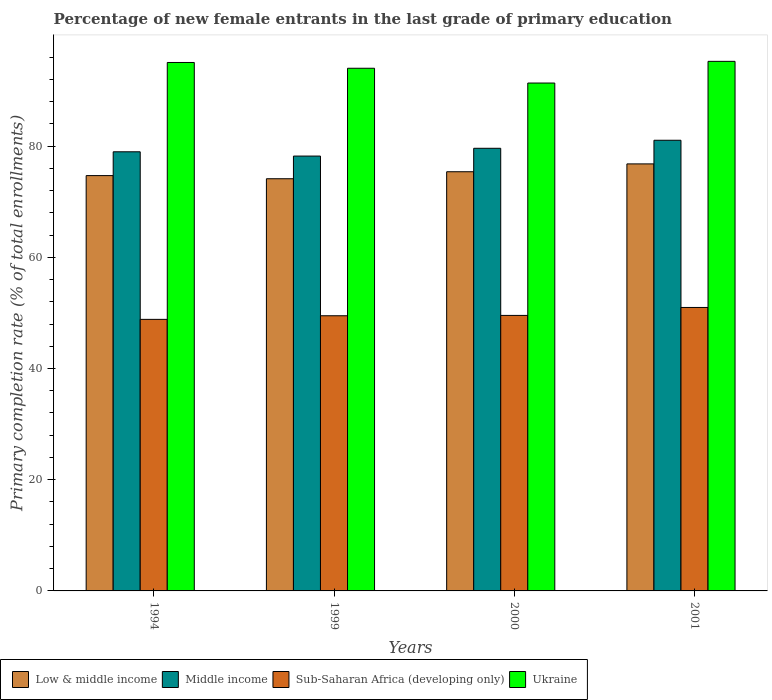Are the number of bars per tick equal to the number of legend labels?
Make the answer very short. Yes. How many bars are there on the 4th tick from the right?
Make the answer very short. 4. What is the label of the 4th group of bars from the left?
Your answer should be compact. 2001. What is the percentage of new female entrants in Middle income in 1994?
Your answer should be very brief. 78.97. Across all years, what is the maximum percentage of new female entrants in Middle income?
Give a very brief answer. 81.05. Across all years, what is the minimum percentage of new female entrants in Ukraine?
Keep it short and to the point. 91.33. In which year was the percentage of new female entrants in Sub-Saharan Africa (developing only) maximum?
Make the answer very short. 2001. What is the total percentage of new female entrants in Sub-Saharan Africa (developing only) in the graph?
Your answer should be compact. 198.84. What is the difference between the percentage of new female entrants in Middle income in 1994 and that in 1999?
Provide a succinct answer. 0.77. What is the difference between the percentage of new female entrants in Ukraine in 2001 and the percentage of new female entrants in Middle income in 1999?
Make the answer very short. 17.03. What is the average percentage of new female entrants in Middle income per year?
Your response must be concise. 79.45. In the year 2000, what is the difference between the percentage of new female entrants in Middle income and percentage of new female entrants in Low & middle income?
Provide a succinct answer. 4.22. In how many years, is the percentage of new female entrants in Sub-Saharan Africa (developing only) greater than 84 %?
Your response must be concise. 0. What is the ratio of the percentage of new female entrants in Low & middle income in 1994 to that in 1999?
Your response must be concise. 1.01. Is the percentage of new female entrants in Ukraine in 2000 less than that in 2001?
Make the answer very short. Yes. What is the difference between the highest and the second highest percentage of new female entrants in Sub-Saharan Africa (developing only)?
Keep it short and to the point. 1.43. What is the difference between the highest and the lowest percentage of new female entrants in Ukraine?
Make the answer very short. 3.9. Is it the case that in every year, the sum of the percentage of new female entrants in Low & middle income and percentage of new female entrants in Sub-Saharan Africa (developing only) is greater than the percentage of new female entrants in Middle income?
Offer a terse response. Yes. Are all the bars in the graph horizontal?
Your response must be concise. No. What is the difference between two consecutive major ticks on the Y-axis?
Provide a short and direct response. 20. Are the values on the major ticks of Y-axis written in scientific E-notation?
Give a very brief answer. No. Does the graph contain grids?
Offer a very short reply. No. Where does the legend appear in the graph?
Your answer should be compact. Bottom left. What is the title of the graph?
Provide a short and direct response. Percentage of new female entrants in the last grade of primary education. What is the label or title of the Y-axis?
Your answer should be compact. Primary completion rate (% of total enrollments). What is the Primary completion rate (% of total enrollments) of Low & middle income in 1994?
Your response must be concise. 74.69. What is the Primary completion rate (% of total enrollments) in Middle income in 1994?
Your answer should be compact. 78.97. What is the Primary completion rate (% of total enrollments) of Sub-Saharan Africa (developing only) in 1994?
Ensure brevity in your answer.  48.84. What is the Primary completion rate (% of total enrollments) in Ukraine in 1994?
Provide a succinct answer. 95.03. What is the Primary completion rate (% of total enrollments) of Low & middle income in 1999?
Your response must be concise. 74.12. What is the Primary completion rate (% of total enrollments) in Middle income in 1999?
Give a very brief answer. 78.2. What is the Primary completion rate (% of total enrollments) of Sub-Saharan Africa (developing only) in 1999?
Provide a succinct answer. 49.48. What is the Primary completion rate (% of total enrollments) in Ukraine in 1999?
Provide a succinct answer. 93.99. What is the Primary completion rate (% of total enrollments) in Low & middle income in 2000?
Keep it short and to the point. 75.38. What is the Primary completion rate (% of total enrollments) of Middle income in 2000?
Offer a terse response. 79.6. What is the Primary completion rate (% of total enrollments) in Sub-Saharan Africa (developing only) in 2000?
Provide a succinct answer. 49.55. What is the Primary completion rate (% of total enrollments) of Ukraine in 2000?
Your answer should be very brief. 91.33. What is the Primary completion rate (% of total enrollments) of Low & middle income in 2001?
Keep it short and to the point. 76.79. What is the Primary completion rate (% of total enrollments) of Middle income in 2001?
Ensure brevity in your answer.  81.05. What is the Primary completion rate (% of total enrollments) of Sub-Saharan Africa (developing only) in 2001?
Keep it short and to the point. 50.98. What is the Primary completion rate (% of total enrollments) of Ukraine in 2001?
Provide a short and direct response. 95.24. Across all years, what is the maximum Primary completion rate (% of total enrollments) of Low & middle income?
Provide a short and direct response. 76.79. Across all years, what is the maximum Primary completion rate (% of total enrollments) in Middle income?
Provide a short and direct response. 81.05. Across all years, what is the maximum Primary completion rate (% of total enrollments) in Sub-Saharan Africa (developing only)?
Offer a terse response. 50.98. Across all years, what is the maximum Primary completion rate (% of total enrollments) in Ukraine?
Make the answer very short. 95.24. Across all years, what is the minimum Primary completion rate (% of total enrollments) in Low & middle income?
Provide a succinct answer. 74.12. Across all years, what is the minimum Primary completion rate (% of total enrollments) of Middle income?
Keep it short and to the point. 78.2. Across all years, what is the minimum Primary completion rate (% of total enrollments) of Sub-Saharan Africa (developing only)?
Provide a succinct answer. 48.84. Across all years, what is the minimum Primary completion rate (% of total enrollments) in Ukraine?
Ensure brevity in your answer.  91.33. What is the total Primary completion rate (% of total enrollments) of Low & middle income in the graph?
Give a very brief answer. 300.99. What is the total Primary completion rate (% of total enrollments) of Middle income in the graph?
Offer a terse response. 317.82. What is the total Primary completion rate (% of total enrollments) of Sub-Saharan Africa (developing only) in the graph?
Provide a succinct answer. 198.84. What is the total Primary completion rate (% of total enrollments) of Ukraine in the graph?
Keep it short and to the point. 375.6. What is the difference between the Primary completion rate (% of total enrollments) of Low & middle income in 1994 and that in 1999?
Your answer should be very brief. 0.56. What is the difference between the Primary completion rate (% of total enrollments) in Middle income in 1994 and that in 1999?
Give a very brief answer. 0.77. What is the difference between the Primary completion rate (% of total enrollments) of Sub-Saharan Africa (developing only) in 1994 and that in 1999?
Give a very brief answer. -0.65. What is the difference between the Primary completion rate (% of total enrollments) of Ukraine in 1994 and that in 1999?
Keep it short and to the point. 1.04. What is the difference between the Primary completion rate (% of total enrollments) of Low & middle income in 1994 and that in 2000?
Ensure brevity in your answer.  -0.69. What is the difference between the Primary completion rate (% of total enrollments) in Middle income in 1994 and that in 2000?
Keep it short and to the point. -0.63. What is the difference between the Primary completion rate (% of total enrollments) in Sub-Saharan Africa (developing only) in 1994 and that in 2000?
Your answer should be very brief. -0.71. What is the difference between the Primary completion rate (% of total enrollments) of Low & middle income in 1994 and that in 2001?
Offer a very short reply. -2.1. What is the difference between the Primary completion rate (% of total enrollments) in Middle income in 1994 and that in 2001?
Your answer should be very brief. -2.07. What is the difference between the Primary completion rate (% of total enrollments) of Sub-Saharan Africa (developing only) in 1994 and that in 2001?
Make the answer very short. -2.14. What is the difference between the Primary completion rate (% of total enrollments) of Ukraine in 1994 and that in 2001?
Make the answer very short. -0.2. What is the difference between the Primary completion rate (% of total enrollments) in Low & middle income in 1999 and that in 2000?
Provide a succinct answer. -1.26. What is the difference between the Primary completion rate (% of total enrollments) in Middle income in 1999 and that in 2000?
Give a very brief answer. -1.4. What is the difference between the Primary completion rate (% of total enrollments) in Sub-Saharan Africa (developing only) in 1999 and that in 2000?
Provide a short and direct response. -0.06. What is the difference between the Primary completion rate (% of total enrollments) in Ukraine in 1999 and that in 2000?
Offer a terse response. 2.66. What is the difference between the Primary completion rate (% of total enrollments) of Low & middle income in 1999 and that in 2001?
Keep it short and to the point. -2.67. What is the difference between the Primary completion rate (% of total enrollments) of Middle income in 1999 and that in 2001?
Provide a succinct answer. -2.84. What is the difference between the Primary completion rate (% of total enrollments) of Sub-Saharan Africa (developing only) in 1999 and that in 2001?
Your answer should be very brief. -1.49. What is the difference between the Primary completion rate (% of total enrollments) of Ukraine in 1999 and that in 2001?
Ensure brevity in your answer.  -1.24. What is the difference between the Primary completion rate (% of total enrollments) in Low & middle income in 2000 and that in 2001?
Give a very brief answer. -1.41. What is the difference between the Primary completion rate (% of total enrollments) of Middle income in 2000 and that in 2001?
Your answer should be compact. -1.44. What is the difference between the Primary completion rate (% of total enrollments) in Sub-Saharan Africa (developing only) in 2000 and that in 2001?
Offer a terse response. -1.43. What is the difference between the Primary completion rate (% of total enrollments) in Ukraine in 2000 and that in 2001?
Your response must be concise. -3.9. What is the difference between the Primary completion rate (% of total enrollments) in Low & middle income in 1994 and the Primary completion rate (% of total enrollments) in Middle income in 1999?
Give a very brief answer. -3.51. What is the difference between the Primary completion rate (% of total enrollments) in Low & middle income in 1994 and the Primary completion rate (% of total enrollments) in Sub-Saharan Africa (developing only) in 1999?
Give a very brief answer. 25.21. What is the difference between the Primary completion rate (% of total enrollments) of Low & middle income in 1994 and the Primary completion rate (% of total enrollments) of Ukraine in 1999?
Your answer should be very brief. -19.3. What is the difference between the Primary completion rate (% of total enrollments) of Middle income in 1994 and the Primary completion rate (% of total enrollments) of Sub-Saharan Africa (developing only) in 1999?
Make the answer very short. 29.49. What is the difference between the Primary completion rate (% of total enrollments) of Middle income in 1994 and the Primary completion rate (% of total enrollments) of Ukraine in 1999?
Provide a succinct answer. -15.02. What is the difference between the Primary completion rate (% of total enrollments) of Sub-Saharan Africa (developing only) in 1994 and the Primary completion rate (% of total enrollments) of Ukraine in 1999?
Offer a terse response. -45.16. What is the difference between the Primary completion rate (% of total enrollments) of Low & middle income in 1994 and the Primary completion rate (% of total enrollments) of Middle income in 2000?
Provide a succinct answer. -4.91. What is the difference between the Primary completion rate (% of total enrollments) in Low & middle income in 1994 and the Primary completion rate (% of total enrollments) in Sub-Saharan Africa (developing only) in 2000?
Your response must be concise. 25.14. What is the difference between the Primary completion rate (% of total enrollments) of Low & middle income in 1994 and the Primary completion rate (% of total enrollments) of Ukraine in 2000?
Ensure brevity in your answer.  -16.65. What is the difference between the Primary completion rate (% of total enrollments) of Middle income in 1994 and the Primary completion rate (% of total enrollments) of Sub-Saharan Africa (developing only) in 2000?
Keep it short and to the point. 29.42. What is the difference between the Primary completion rate (% of total enrollments) in Middle income in 1994 and the Primary completion rate (% of total enrollments) in Ukraine in 2000?
Ensure brevity in your answer.  -12.36. What is the difference between the Primary completion rate (% of total enrollments) in Sub-Saharan Africa (developing only) in 1994 and the Primary completion rate (% of total enrollments) in Ukraine in 2000?
Ensure brevity in your answer.  -42.5. What is the difference between the Primary completion rate (% of total enrollments) in Low & middle income in 1994 and the Primary completion rate (% of total enrollments) in Middle income in 2001?
Keep it short and to the point. -6.36. What is the difference between the Primary completion rate (% of total enrollments) of Low & middle income in 1994 and the Primary completion rate (% of total enrollments) of Sub-Saharan Africa (developing only) in 2001?
Provide a succinct answer. 23.71. What is the difference between the Primary completion rate (% of total enrollments) in Low & middle income in 1994 and the Primary completion rate (% of total enrollments) in Ukraine in 2001?
Provide a short and direct response. -20.55. What is the difference between the Primary completion rate (% of total enrollments) of Middle income in 1994 and the Primary completion rate (% of total enrollments) of Sub-Saharan Africa (developing only) in 2001?
Offer a very short reply. 28. What is the difference between the Primary completion rate (% of total enrollments) of Middle income in 1994 and the Primary completion rate (% of total enrollments) of Ukraine in 2001?
Ensure brevity in your answer.  -16.26. What is the difference between the Primary completion rate (% of total enrollments) of Sub-Saharan Africa (developing only) in 1994 and the Primary completion rate (% of total enrollments) of Ukraine in 2001?
Make the answer very short. -46.4. What is the difference between the Primary completion rate (% of total enrollments) of Low & middle income in 1999 and the Primary completion rate (% of total enrollments) of Middle income in 2000?
Keep it short and to the point. -5.48. What is the difference between the Primary completion rate (% of total enrollments) of Low & middle income in 1999 and the Primary completion rate (% of total enrollments) of Sub-Saharan Africa (developing only) in 2000?
Provide a succinct answer. 24.58. What is the difference between the Primary completion rate (% of total enrollments) of Low & middle income in 1999 and the Primary completion rate (% of total enrollments) of Ukraine in 2000?
Offer a terse response. -17.21. What is the difference between the Primary completion rate (% of total enrollments) in Middle income in 1999 and the Primary completion rate (% of total enrollments) in Sub-Saharan Africa (developing only) in 2000?
Your response must be concise. 28.65. What is the difference between the Primary completion rate (% of total enrollments) of Middle income in 1999 and the Primary completion rate (% of total enrollments) of Ukraine in 2000?
Your answer should be very brief. -13.13. What is the difference between the Primary completion rate (% of total enrollments) of Sub-Saharan Africa (developing only) in 1999 and the Primary completion rate (% of total enrollments) of Ukraine in 2000?
Provide a succinct answer. -41.85. What is the difference between the Primary completion rate (% of total enrollments) of Low & middle income in 1999 and the Primary completion rate (% of total enrollments) of Middle income in 2001?
Offer a terse response. -6.92. What is the difference between the Primary completion rate (% of total enrollments) in Low & middle income in 1999 and the Primary completion rate (% of total enrollments) in Sub-Saharan Africa (developing only) in 2001?
Your response must be concise. 23.15. What is the difference between the Primary completion rate (% of total enrollments) in Low & middle income in 1999 and the Primary completion rate (% of total enrollments) in Ukraine in 2001?
Make the answer very short. -21.11. What is the difference between the Primary completion rate (% of total enrollments) in Middle income in 1999 and the Primary completion rate (% of total enrollments) in Sub-Saharan Africa (developing only) in 2001?
Keep it short and to the point. 27.22. What is the difference between the Primary completion rate (% of total enrollments) of Middle income in 1999 and the Primary completion rate (% of total enrollments) of Ukraine in 2001?
Provide a short and direct response. -17.03. What is the difference between the Primary completion rate (% of total enrollments) in Sub-Saharan Africa (developing only) in 1999 and the Primary completion rate (% of total enrollments) in Ukraine in 2001?
Give a very brief answer. -45.75. What is the difference between the Primary completion rate (% of total enrollments) in Low & middle income in 2000 and the Primary completion rate (% of total enrollments) in Middle income in 2001?
Give a very brief answer. -5.66. What is the difference between the Primary completion rate (% of total enrollments) in Low & middle income in 2000 and the Primary completion rate (% of total enrollments) in Sub-Saharan Africa (developing only) in 2001?
Your response must be concise. 24.41. What is the difference between the Primary completion rate (% of total enrollments) of Low & middle income in 2000 and the Primary completion rate (% of total enrollments) of Ukraine in 2001?
Provide a short and direct response. -19.85. What is the difference between the Primary completion rate (% of total enrollments) in Middle income in 2000 and the Primary completion rate (% of total enrollments) in Sub-Saharan Africa (developing only) in 2001?
Give a very brief answer. 28.62. What is the difference between the Primary completion rate (% of total enrollments) of Middle income in 2000 and the Primary completion rate (% of total enrollments) of Ukraine in 2001?
Offer a very short reply. -15.63. What is the difference between the Primary completion rate (% of total enrollments) of Sub-Saharan Africa (developing only) in 2000 and the Primary completion rate (% of total enrollments) of Ukraine in 2001?
Make the answer very short. -45.69. What is the average Primary completion rate (% of total enrollments) of Low & middle income per year?
Provide a short and direct response. 75.25. What is the average Primary completion rate (% of total enrollments) of Middle income per year?
Make the answer very short. 79.45. What is the average Primary completion rate (% of total enrollments) in Sub-Saharan Africa (developing only) per year?
Keep it short and to the point. 49.71. What is the average Primary completion rate (% of total enrollments) in Ukraine per year?
Your answer should be compact. 93.9. In the year 1994, what is the difference between the Primary completion rate (% of total enrollments) in Low & middle income and Primary completion rate (% of total enrollments) in Middle income?
Offer a very short reply. -4.28. In the year 1994, what is the difference between the Primary completion rate (% of total enrollments) in Low & middle income and Primary completion rate (% of total enrollments) in Sub-Saharan Africa (developing only)?
Provide a succinct answer. 25.85. In the year 1994, what is the difference between the Primary completion rate (% of total enrollments) in Low & middle income and Primary completion rate (% of total enrollments) in Ukraine?
Ensure brevity in your answer.  -20.35. In the year 1994, what is the difference between the Primary completion rate (% of total enrollments) of Middle income and Primary completion rate (% of total enrollments) of Sub-Saharan Africa (developing only)?
Your answer should be compact. 30.14. In the year 1994, what is the difference between the Primary completion rate (% of total enrollments) in Middle income and Primary completion rate (% of total enrollments) in Ukraine?
Provide a succinct answer. -16.06. In the year 1994, what is the difference between the Primary completion rate (% of total enrollments) of Sub-Saharan Africa (developing only) and Primary completion rate (% of total enrollments) of Ukraine?
Offer a terse response. -46.2. In the year 1999, what is the difference between the Primary completion rate (% of total enrollments) of Low & middle income and Primary completion rate (% of total enrollments) of Middle income?
Give a very brief answer. -4.08. In the year 1999, what is the difference between the Primary completion rate (% of total enrollments) in Low & middle income and Primary completion rate (% of total enrollments) in Sub-Saharan Africa (developing only)?
Your answer should be compact. 24.64. In the year 1999, what is the difference between the Primary completion rate (% of total enrollments) of Low & middle income and Primary completion rate (% of total enrollments) of Ukraine?
Provide a succinct answer. -19.87. In the year 1999, what is the difference between the Primary completion rate (% of total enrollments) of Middle income and Primary completion rate (% of total enrollments) of Sub-Saharan Africa (developing only)?
Provide a succinct answer. 28.72. In the year 1999, what is the difference between the Primary completion rate (% of total enrollments) in Middle income and Primary completion rate (% of total enrollments) in Ukraine?
Offer a very short reply. -15.79. In the year 1999, what is the difference between the Primary completion rate (% of total enrollments) of Sub-Saharan Africa (developing only) and Primary completion rate (% of total enrollments) of Ukraine?
Give a very brief answer. -44.51. In the year 2000, what is the difference between the Primary completion rate (% of total enrollments) of Low & middle income and Primary completion rate (% of total enrollments) of Middle income?
Make the answer very short. -4.22. In the year 2000, what is the difference between the Primary completion rate (% of total enrollments) in Low & middle income and Primary completion rate (% of total enrollments) in Sub-Saharan Africa (developing only)?
Provide a succinct answer. 25.83. In the year 2000, what is the difference between the Primary completion rate (% of total enrollments) of Low & middle income and Primary completion rate (% of total enrollments) of Ukraine?
Your answer should be very brief. -15.95. In the year 2000, what is the difference between the Primary completion rate (% of total enrollments) in Middle income and Primary completion rate (% of total enrollments) in Sub-Saharan Africa (developing only)?
Your answer should be compact. 30.05. In the year 2000, what is the difference between the Primary completion rate (% of total enrollments) in Middle income and Primary completion rate (% of total enrollments) in Ukraine?
Provide a short and direct response. -11.73. In the year 2000, what is the difference between the Primary completion rate (% of total enrollments) in Sub-Saharan Africa (developing only) and Primary completion rate (% of total enrollments) in Ukraine?
Your response must be concise. -41.79. In the year 2001, what is the difference between the Primary completion rate (% of total enrollments) in Low & middle income and Primary completion rate (% of total enrollments) in Middle income?
Keep it short and to the point. -4.25. In the year 2001, what is the difference between the Primary completion rate (% of total enrollments) in Low & middle income and Primary completion rate (% of total enrollments) in Sub-Saharan Africa (developing only)?
Ensure brevity in your answer.  25.82. In the year 2001, what is the difference between the Primary completion rate (% of total enrollments) of Low & middle income and Primary completion rate (% of total enrollments) of Ukraine?
Your answer should be compact. -18.44. In the year 2001, what is the difference between the Primary completion rate (% of total enrollments) in Middle income and Primary completion rate (% of total enrollments) in Sub-Saharan Africa (developing only)?
Offer a very short reply. 30.07. In the year 2001, what is the difference between the Primary completion rate (% of total enrollments) in Middle income and Primary completion rate (% of total enrollments) in Ukraine?
Keep it short and to the point. -14.19. In the year 2001, what is the difference between the Primary completion rate (% of total enrollments) in Sub-Saharan Africa (developing only) and Primary completion rate (% of total enrollments) in Ukraine?
Make the answer very short. -44.26. What is the ratio of the Primary completion rate (% of total enrollments) of Low & middle income in 1994 to that in 1999?
Offer a very short reply. 1.01. What is the ratio of the Primary completion rate (% of total enrollments) in Middle income in 1994 to that in 1999?
Provide a succinct answer. 1.01. What is the ratio of the Primary completion rate (% of total enrollments) in Sub-Saharan Africa (developing only) in 1994 to that in 1999?
Keep it short and to the point. 0.99. What is the ratio of the Primary completion rate (% of total enrollments) in Ukraine in 1994 to that in 1999?
Provide a short and direct response. 1.01. What is the ratio of the Primary completion rate (% of total enrollments) in Low & middle income in 1994 to that in 2000?
Keep it short and to the point. 0.99. What is the ratio of the Primary completion rate (% of total enrollments) of Middle income in 1994 to that in 2000?
Make the answer very short. 0.99. What is the ratio of the Primary completion rate (% of total enrollments) of Sub-Saharan Africa (developing only) in 1994 to that in 2000?
Your response must be concise. 0.99. What is the ratio of the Primary completion rate (% of total enrollments) of Ukraine in 1994 to that in 2000?
Offer a terse response. 1.04. What is the ratio of the Primary completion rate (% of total enrollments) of Low & middle income in 1994 to that in 2001?
Provide a succinct answer. 0.97. What is the ratio of the Primary completion rate (% of total enrollments) of Middle income in 1994 to that in 2001?
Offer a very short reply. 0.97. What is the ratio of the Primary completion rate (% of total enrollments) of Sub-Saharan Africa (developing only) in 1994 to that in 2001?
Give a very brief answer. 0.96. What is the ratio of the Primary completion rate (% of total enrollments) in Low & middle income in 1999 to that in 2000?
Make the answer very short. 0.98. What is the ratio of the Primary completion rate (% of total enrollments) in Middle income in 1999 to that in 2000?
Give a very brief answer. 0.98. What is the ratio of the Primary completion rate (% of total enrollments) in Sub-Saharan Africa (developing only) in 1999 to that in 2000?
Give a very brief answer. 1. What is the ratio of the Primary completion rate (% of total enrollments) in Ukraine in 1999 to that in 2000?
Provide a short and direct response. 1.03. What is the ratio of the Primary completion rate (% of total enrollments) in Low & middle income in 1999 to that in 2001?
Your answer should be very brief. 0.97. What is the ratio of the Primary completion rate (% of total enrollments) in Middle income in 1999 to that in 2001?
Keep it short and to the point. 0.96. What is the ratio of the Primary completion rate (% of total enrollments) of Sub-Saharan Africa (developing only) in 1999 to that in 2001?
Provide a short and direct response. 0.97. What is the ratio of the Primary completion rate (% of total enrollments) of Ukraine in 1999 to that in 2001?
Your response must be concise. 0.99. What is the ratio of the Primary completion rate (% of total enrollments) of Low & middle income in 2000 to that in 2001?
Your answer should be compact. 0.98. What is the ratio of the Primary completion rate (% of total enrollments) in Middle income in 2000 to that in 2001?
Provide a short and direct response. 0.98. What is the ratio of the Primary completion rate (% of total enrollments) of Sub-Saharan Africa (developing only) in 2000 to that in 2001?
Provide a short and direct response. 0.97. What is the difference between the highest and the second highest Primary completion rate (% of total enrollments) of Low & middle income?
Make the answer very short. 1.41. What is the difference between the highest and the second highest Primary completion rate (% of total enrollments) of Middle income?
Your answer should be compact. 1.44. What is the difference between the highest and the second highest Primary completion rate (% of total enrollments) of Sub-Saharan Africa (developing only)?
Provide a short and direct response. 1.43. What is the difference between the highest and the second highest Primary completion rate (% of total enrollments) in Ukraine?
Ensure brevity in your answer.  0.2. What is the difference between the highest and the lowest Primary completion rate (% of total enrollments) in Low & middle income?
Keep it short and to the point. 2.67. What is the difference between the highest and the lowest Primary completion rate (% of total enrollments) of Middle income?
Keep it short and to the point. 2.84. What is the difference between the highest and the lowest Primary completion rate (% of total enrollments) in Sub-Saharan Africa (developing only)?
Provide a succinct answer. 2.14. What is the difference between the highest and the lowest Primary completion rate (% of total enrollments) of Ukraine?
Your answer should be compact. 3.9. 